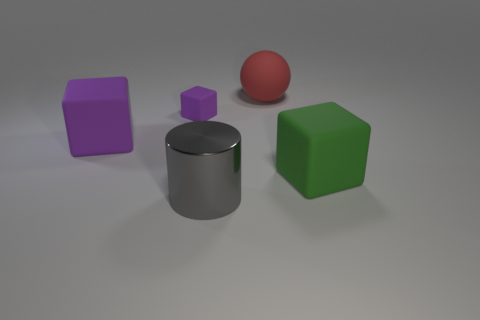What number of other things are there of the same color as the tiny matte thing?
Make the answer very short. 1. There is a large block that is on the right side of the gray shiny object; is there a big gray object that is behind it?
Your response must be concise. No. How big is the gray metal cylinder?
Ensure brevity in your answer.  Large. The thing that is both behind the large purple matte thing and on the right side of the large metallic cylinder has what shape?
Provide a short and direct response. Sphere. What number of brown things are big objects or matte balls?
Offer a very short reply. 0. There is a object in front of the green thing; is it the same size as the object on the left side of the small object?
Give a very brief answer. Yes. What number of things are large cyan rubber objects or matte objects?
Make the answer very short. 4. Are there any tiny purple things of the same shape as the large green rubber thing?
Your response must be concise. Yes. Are there fewer big red matte objects than tiny yellow balls?
Ensure brevity in your answer.  No. Does the large purple rubber thing have the same shape as the red thing?
Offer a terse response. No. 